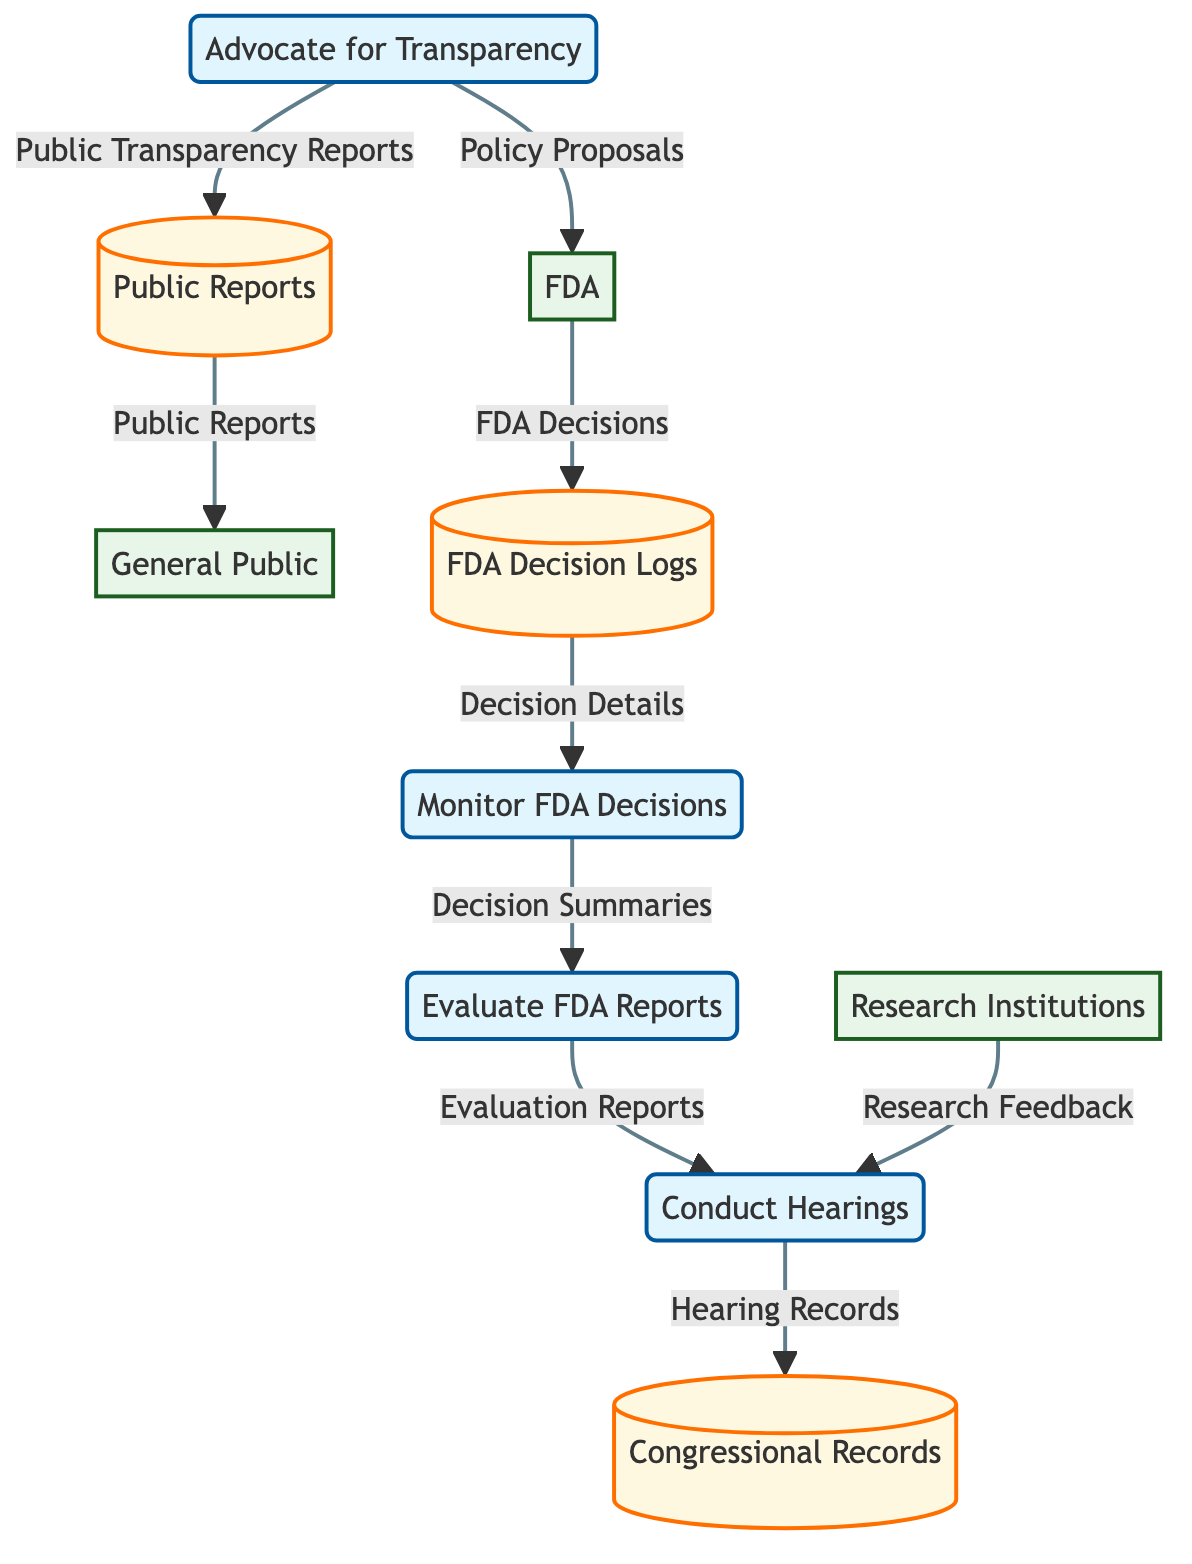What is the name of the process that involves monitoring FDA decisions? The process labeled as P1 in the diagram is "Monitor FDA Decisions." This is directly obtained from the node labeled P1 in the diagram.
Answer: Monitor FDA Decisions How many data stores are present in the diagram? There are three data stores indicated in the diagram: FDA Decision Logs, Congressional Records, and Public Reports. Counting these nodes gives a total of three data stores.
Answer: 3 What kind of feedback flows from research institutions to congressional hearings? The flow from research institutions to the process "Conduct Hearings" is labeled as "Research Feedback." Reviewing the connection between the external entity "Research Institutions" and the process P3 shows this flow.
Answer: Research Feedback Which entity submits proposals for enhancing transparency to the FDA? The process labeled P4, "Advocate for Transparency," flows to the FDA with data labeled as "Policy Proposals," indicating that this process submits proposals for transparency.
Answer: FDA What do the public reports created for public dissemination contain? The process P4 sends the data labeled as "Public Transparency Reports" to the data store "Public Reports." These reports are intended for public dissemination according to the flow description.
Answer: Public Transparency Reports Which process is primarily concerned with evaluating FDA reports? The process referred to as P2 in the diagram is explicitly named "Evaluate FDA Reports." This is indicated directly in the label for process P2.
Answer: Evaluate FDA Reports What type of document is generated from evaluating FDA decisions? The flow from process P2 to process P3 indicates that "Evaluation Reports" are generated from the evaluation of FDA decisions. This relationship is clearly labeled in the diagram.
Answer: Evaluation Reports Which data flows from FDA Decision Logs to the process that monitors FDA decisions? The flow labeled "Decision Details" moves from the data store "FDA Decision Logs" to the process "Monitor FDA Decisions." Following the arrow indicates this connection.
Answer: Decision Details What is the outcome of congressional hearings as recorded in the diagram? The outcome from process P3, "Conduct Hearings," is labeled as "Hearing Records," which flows into the data store "Congressional Records." This shows that the outcome is the records of those hearings.
Answer: Hearing Records 